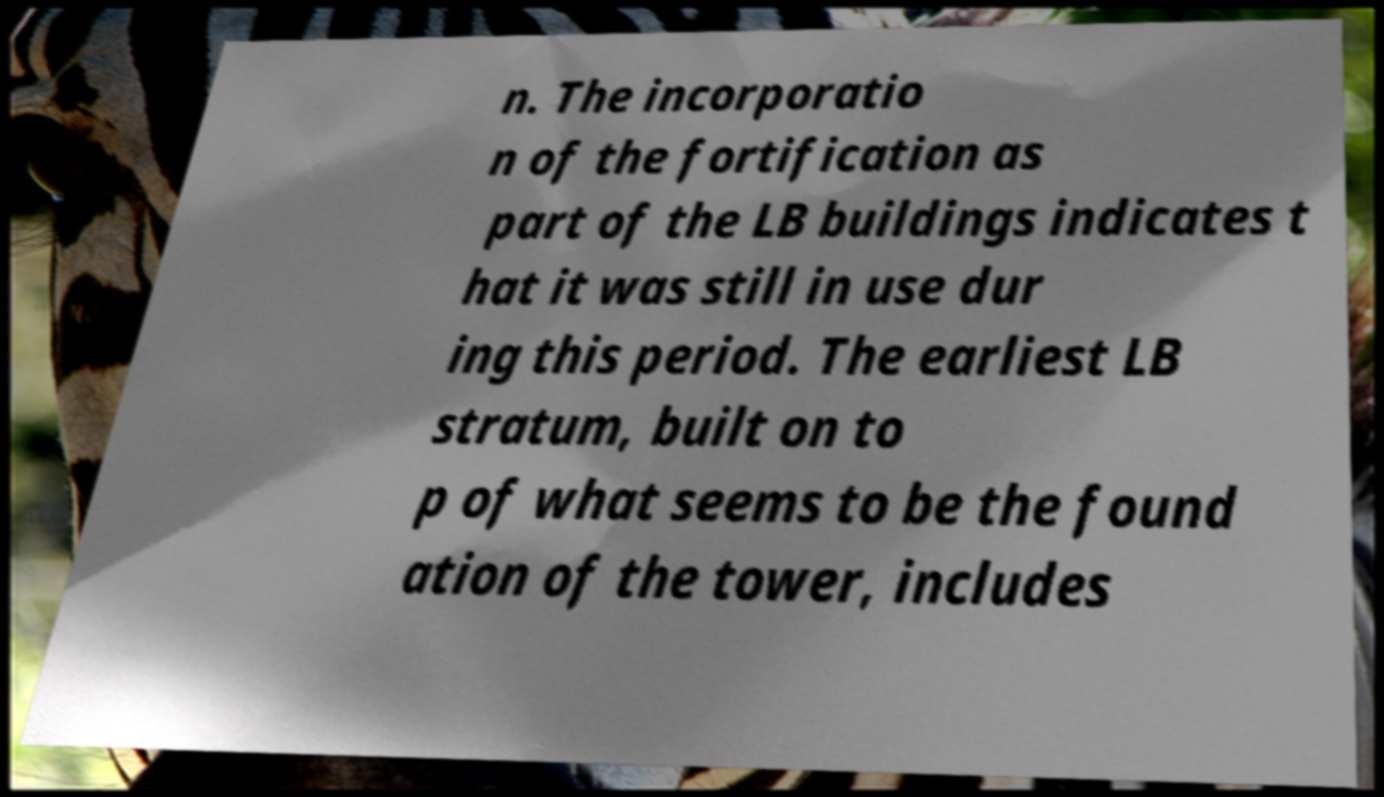What messages or text are displayed in this image? I need them in a readable, typed format. n. The incorporatio n of the fortification as part of the LB buildings indicates t hat it was still in use dur ing this period. The earliest LB stratum, built on to p of what seems to be the found ation of the tower, includes 